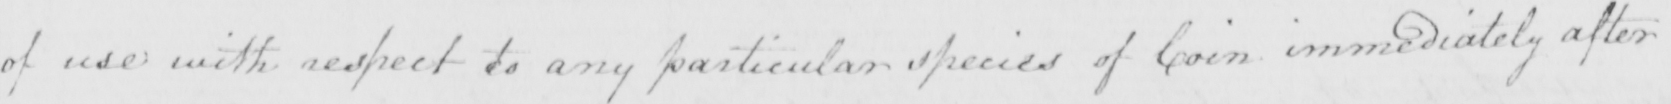Can you read and transcribe this handwriting? of use with respect to any particular species of Coin immediately after 